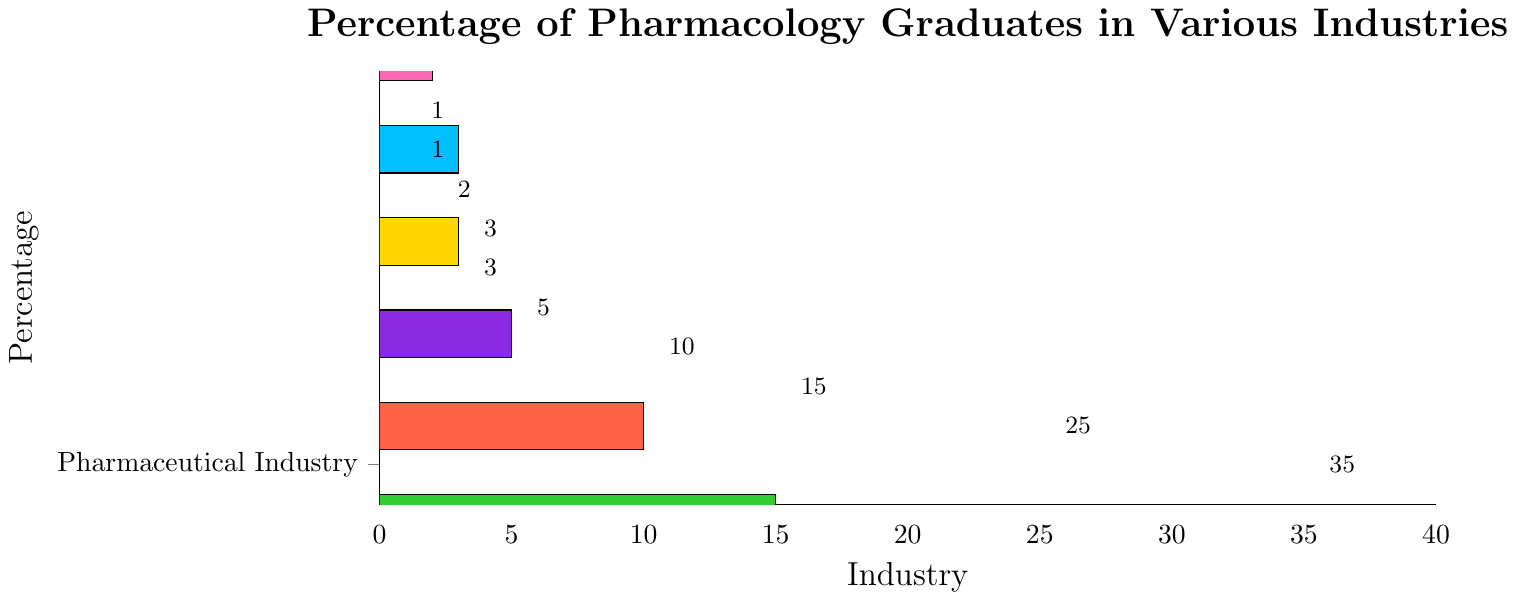What's the highest percentage of pharmacology graduates pursuing careers and in which industry? The bar chart shows that the highest percentage bar reaches a value of 35, corresponding to the Pharmaceutical Industry.
Answer: 35%, Pharmaceutical Industry Which industries have an equal percentage of pharmacology graduates? The chart shows Medical Writing and Regulatory Affairs both have a percentage of 3.
Answer: Medical Writing, Regulatory Affairs What is the total percentage of pharmacology graduates in Academia, Biotechnology, and Clinical Research Organizations? Add the percentages of the three industries: 25 (Academia) + 15 (Biotechnology) + 10 (Clinical Research Organizations) = 50.
Answer: 50% Is the percentage of graduates in Government Agencies higher or lower than that in Healthcare Consulting? Compare the two percentages: 5 (Government Agencies) is greater than 2 (Healthcare Consulting).
Answer: Higher How much higher is the percentage of pharmacology graduates in the Pharmaceutical Industry compared to Academia? Subtract the percentage of Academia (25) from Pharmaceutical Industry (35): 35 - 25 = 10.
Answer: 10 percentage points Which industry has the lowest percentage of pharmacology graduates and what is it? The bar corresponding to Drug Safety and Pharmacovigilance reaches 1, which is the lowest.
Answer: Drug Safety and Pharmacovigilance, 1% What is the average percentage of pharmacology graduates in the bottom three industries? Add the percentages of Drug Safety and Pharmacovigilance (1), Medical Science Liaison (1), and Healthcare Consulting (2) then divide by 3: (1 + 1 + 2) / 3 = 1.33.
Answer: 1.33% What is the combined percentage of graduates in Medical Writing, Regulatory Affairs, and Healthcare Consulting? Add the percentages for these industries: 3 (Medical Writing) + 3 (Regulatory Affairs) + 2 (Healthcare Consulting) = 8.
Answer: 8% What percentage of pharmacology graduates pursue career paths other than the Pharmaceutical Industry, Academia, and Biotechnology? Subtract the sum of percentages of these three industries from 100: 100 - (35 + 25 + 15) = 25.
Answer: 25% What color is associated with the industry most pharmacology graduates pursue their careers in? The Pharmaceutical Industry is the industry with the highest percentage (35), and its bar is colored blue.
Answer: Blue 